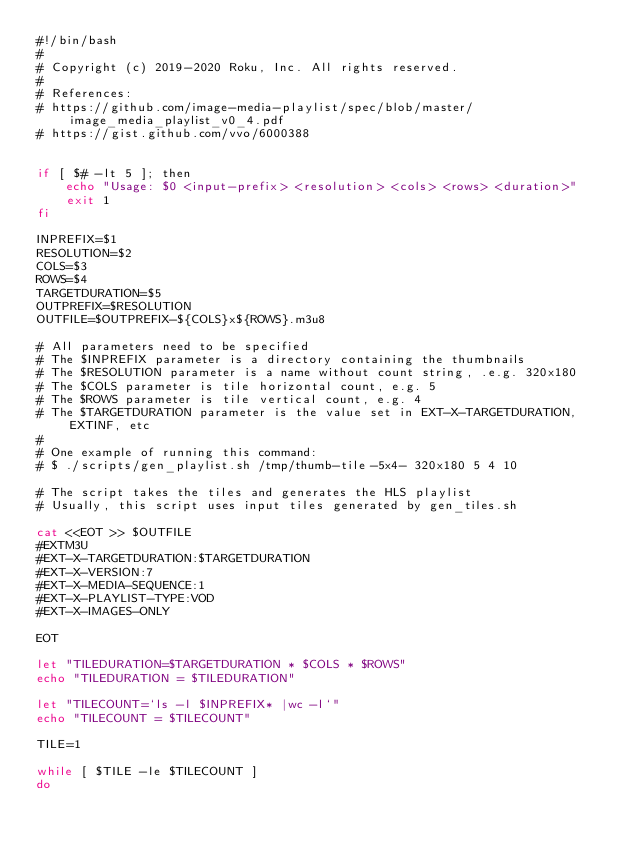<code> <loc_0><loc_0><loc_500><loc_500><_Bash_>#!/bin/bash
#
# Copyright (c) 2019-2020 Roku, Inc. All rights reserved.
#
# References:
# https://github.com/image-media-playlist/spec/blob/master/image_media_playlist_v0_4.pdf
# https://gist.github.com/vvo/6000388


if [ $# -lt 5 ]; then
    echo "Usage: $0 <input-prefix> <resolution> <cols> <rows> <duration>"
    exit 1
fi

INPREFIX=$1
RESOLUTION=$2
COLS=$3
ROWS=$4
TARGETDURATION=$5
OUTPREFIX=$RESOLUTION
OUTFILE=$OUTPREFIX-${COLS}x${ROWS}.m3u8

# All parameters need to be specified
# The $INPREFIX parameter is a directory containing the thumbnails
# The $RESOLUTION parameter is a name without count string, .e.g. 320x180
# The $COLS parameter is tile horizontal count, e.g. 5
# The $ROWS parameter is tile vertical count, e.g. 4
# The $TARGETDURATION parameter is the value set in EXT-X-TARGETDURATION, EXTINF, etc
#
# One example of running this command:
# $ ./scripts/gen_playlist.sh /tmp/thumb-tile-5x4- 320x180 5 4 10

# The script takes the tiles and generates the HLS playlist
# Usually, this script uses input tiles generated by gen_tiles.sh

cat <<EOT >> $OUTFILE
#EXTM3U
#EXT-X-TARGETDURATION:$TARGETDURATION
#EXT-X-VERSION:7
#EXT-X-MEDIA-SEQUENCE:1
#EXT-X-PLAYLIST-TYPE:VOD
#EXT-X-IMAGES-ONLY

EOT

let "TILEDURATION=$TARGETDURATION * $COLS * $ROWS"
echo "TILEDURATION = $TILEDURATION"

let "TILECOUNT=`ls -l $INPREFIX* |wc -l`"
echo "TILECOUNT = $TILECOUNT"

TILE=1

while [ $TILE -le $TILECOUNT ]
do</code> 